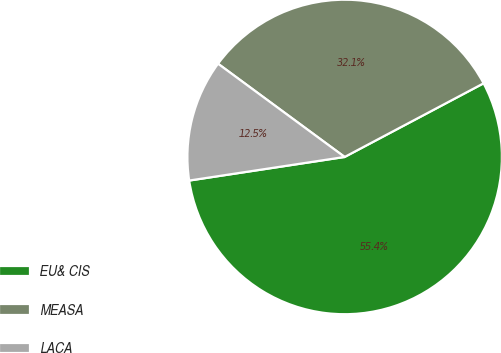Convert chart to OTSL. <chart><loc_0><loc_0><loc_500><loc_500><pie_chart><fcel>EU& CIS<fcel>MEASA<fcel>LACA<nl><fcel>55.36%<fcel>32.14%<fcel>12.5%<nl></chart> 